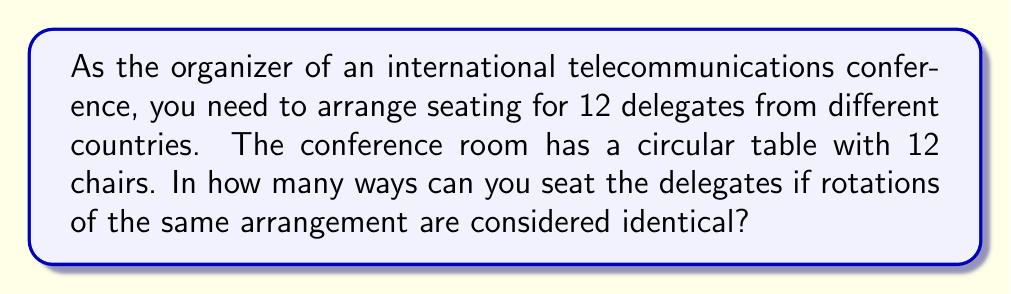Provide a solution to this math problem. Let's approach this step-by-step:

1) First, we need to recognize that this is a circular permutation problem. In a circular arrangement, rotations of the same arrangement are considered identical.

2) For a linear arrangement of 12 people, we would have 12! ways. However, for a circular arrangement, we need to divide by the number of rotations possible.

3) The number of rotations possible is equal to the number of delegates, which is 12 in this case.

4) Therefore, the formula for circular permutations is:

   $$\frac{(n-1)!}{1} = (n-1)!$$

   Where n is the number of delegates.

5) In this case, n = 12, so we need to calculate:

   $$(12-1)! = 11!$$

6) Let's calculate this:
   
   $$11! = 11 \times 10 \times 9 \times 8 \times 7 \times 6 \times 5 \times 4 \times 3 \times 2 \times 1 = 39,916,800$$

Therefore, there are 39,916,800 ways to arrange the 12 international delegates around the circular table.
Answer: 39,916,800 